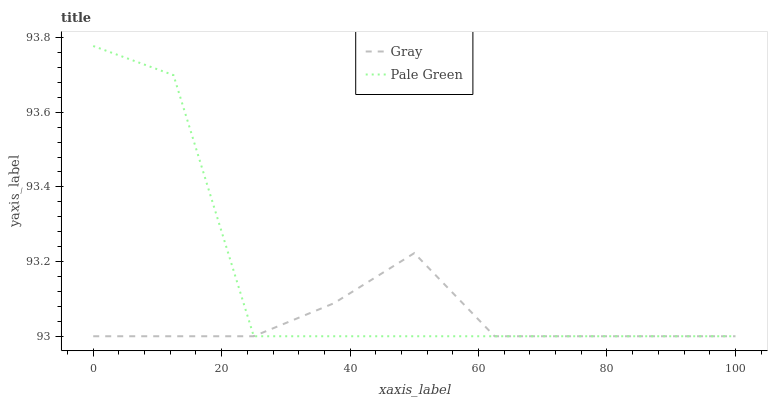Does Gray have the minimum area under the curve?
Answer yes or no. Yes. Does Pale Green have the maximum area under the curve?
Answer yes or no. Yes. Does Pale Green have the minimum area under the curve?
Answer yes or no. No. Is Gray the smoothest?
Answer yes or no. Yes. Is Pale Green the roughest?
Answer yes or no. Yes. Is Pale Green the smoothest?
Answer yes or no. No. Does Gray have the lowest value?
Answer yes or no. Yes. Does Pale Green have the highest value?
Answer yes or no. Yes. Does Pale Green intersect Gray?
Answer yes or no. Yes. Is Pale Green less than Gray?
Answer yes or no. No. Is Pale Green greater than Gray?
Answer yes or no. No. 